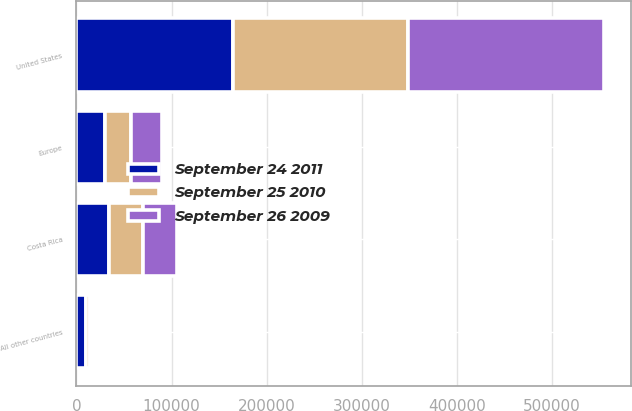Convert chart. <chart><loc_0><loc_0><loc_500><loc_500><stacked_bar_chart><ecel><fcel>United States<fcel>Costa Rica<fcel>Europe<fcel>All other countries<nl><fcel>September 24 2011<fcel>165177<fcel>34107<fcel>29591<fcel>9791<nl><fcel>September 25 2010<fcel>183383<fcel>35984<fcel>28060<fcel>4271<nl><fcel>September 26 2009<fcel>206630<fcel>35886<fcel>32328<fcel>3533<nl></chart> 